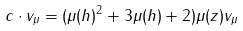<formula> <loc_0><loc_0><loc_500><loc_500>c \cdot v _ { \mu } = ( \mu ( h ) ^ { 2 } + 3 \mu ( h ) + 2 ) \mu ( z ) v _ { \mu }</formula> 